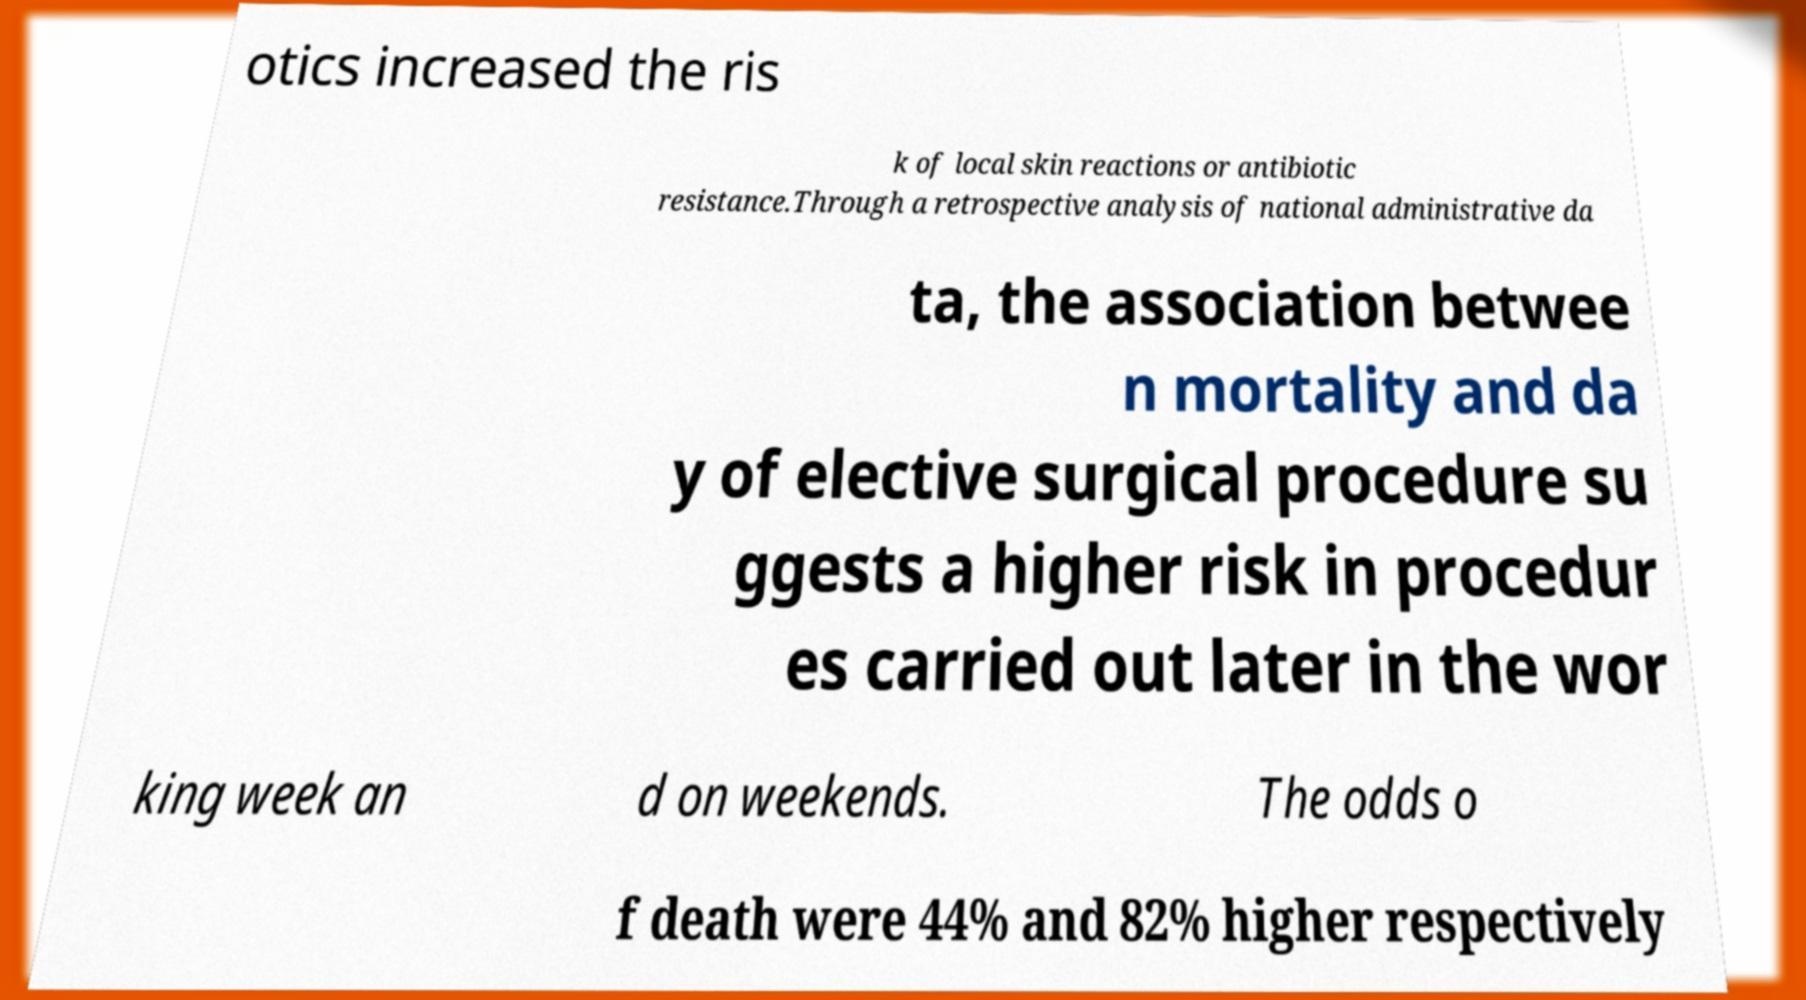Could you assist in decoding the text presented in this image and type it out clearly? otics increased the ris k of local skin reactions or antibiotic resistance.Through a retrospective analysis of national administrative da ta, the association betwee n mortality and da y of elective surgical procedure su ggests a higher risk in procedur es carried out later in the wor king week an d on weekends. The odds o f death were 44% and 82% higher respectively 